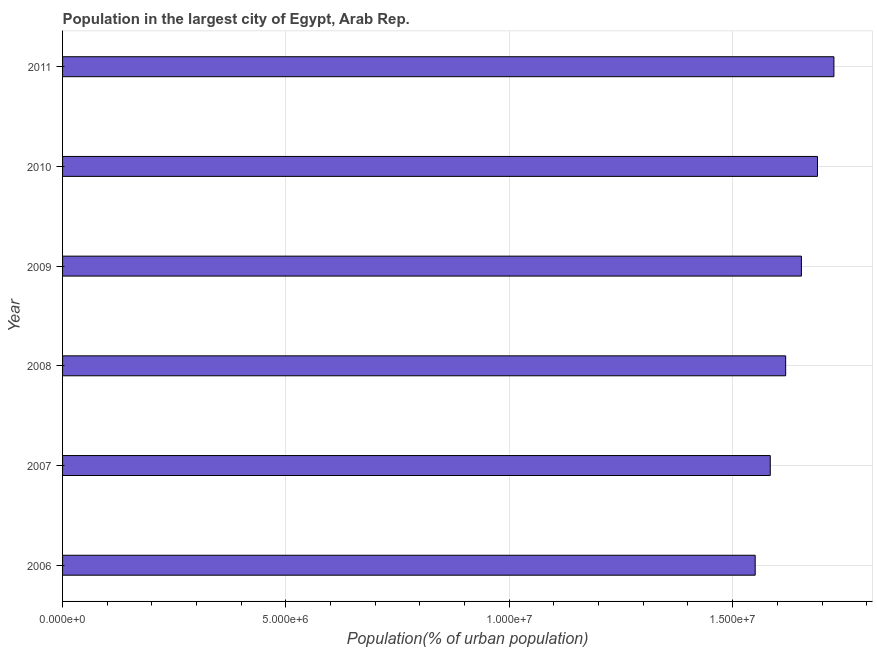Does the graph contain grids?
Provide a short and direct response. Yes. What is the title of the graph?
Your response must be concise. Population in the largest city of Egypt, Arab Rep. What is the label or title of the X-axis?
Your answer should be compact. Population(% of urban population). What is the label or title of the Y-axis?
Provide a short and direct response. Year. What is the population in largest city in 2007?
Provide a succinct answer. 1.58e+07. Across all years, what is the maximum population in largest city?
Provide a short and direct response. 1.73e+07. Across all years, what is the minimum population in largest city?
Provide a succinct answer. 1.55e+07. What is the sum of the population in largest city?
Offer a very short reply. 9.82e+07. What is the difference between the population in largest city in 2006 and 2010?
Give a very brief answer. -1.39e+06. What is the average population in largest city per year?
Ensure brevity in your answer.  1.64e+07. What is the median population in largest city?
Offer a very short reply. 1.64e+07. What is the ratio of the population in largest city in 2006 to that in 2009?
Offer a very short reply. 0.94. What is the difference between the highest and the second highest population in largest city?
Provide a succinct answer. 3.68e+05. What is the difference between the highest and the lowest population in largest city?
Ensure brevity in your answer.  1.76e+06. How many years are there in the graph?
Give a very brief answer. 6. Are the values on the major ticks of X-axis written in scientific E-notation?
Provide a short and direct response. Yes. What is the Population(% of urban population) of 2006?
Your answer should be very brief. 1.55e+07. What is the Population(% of urban population) of 2007?
Give a very brief answer. 1.58e+07. What is the Population(% of urban population) of 2008?
Offer a terse response. 1.62e+07. What is the Population(% of urban population) of 2009?
Your answer should be very brief. 1.65e+07. What is the Population(% of urban population) in 2010?
Your response must be concise. 1.69e+07. What is the Population(% of urban population) of 2011?
Keep it short and to the point. 1.73e+07. What is the difference between the Population(% of urban population) in 2006 and 2007?
Keep it short and to the point. -3.37e+05. What is the difference between the Population(% of urban population) in 2006 and 2008?
Offer a very short reply. -6.82e+05. What is the difference between the Population(% of urban population) in 2006 and 2009?
Keep it short and to the point. -1.03e+06. What is the difference between the Population(% of urban population) in 2006 and 2010?
Ensure brevity in your answer.  -1.39e+06. What is the difference between the Population(% of urban population) in 2006 and 2011?
Ensure brevity in your answer.  -1.76e+06. What is the difference between the Population(% of urban population) in 2007 and 2008?
Offer a terse response. -3.45e+05. What is the difference between the Population(% of urban population) in 2007 and 2009?
Ensure brevity in your answer.  -6.97e+05. What is the difference between the Population(% of urban population) in 2007 and 2010?
Your answer should be compact. -1.06e+06. What is the difference between the Population(% of urban population) in 2007 and 2011?
Give a very brief answer. -1.43e+06. What is the difference between the Population(% of urban population) in 2008 and 2009?
Give a very brief answer. -3.52e+05. What is the difference between the Population(% of urban population) in 2008 and 2010?
Offer a terse response. -7.12e+05. What is the difference between the Population(% of urban population) in 2008 and 2011?
Your answer should be very brief. -1.08e+06. What is the difference between the Population(% of urban population) in 2009 and 2010?
Your answer should be very brief. -3.60e+05. What is the difference between the Population(% of urban population) in 2009 and 2011?
Your answer should be very brief. -7.28e+05. What is the difference between the Population(% of urban population) in 2010 and 2011?
Your answer should be compact. -3.68e+05. What is the ratio of the Population(% of urban population) in 2006 to that in 2007?
Provide a short and direct response. 0.98. What is the ratio of the Population(% of urban population) in 2006 to that in 2008?
Keep it short and to the point. 0.96. What is the ratio of the Population(% of urban population) in 2006 to that in 2009?
Give a very brief answer. 0.94. What is the ratio of the Population(% of urban population) in 2006 to that in 2010?
Give a very brief answer. 0.92. What is the ratio of the Population(% of urban population) in 2006 to that in 2011?
Offer a very short reply. 0.9. What is the ratio of the Population(% of urban population) in 2007 to that in 2008?
Your answer should be compact. 0.98. What is the ratio of the Population(% of urban population) in 2007 to that in 2009?
Make the answer very short. 0.96. What is the ratio of the Population(% of urban population) in 2007 to that in 2010?
Give a very brief answer. 0.94. What is the ratio of the Population(% of urban population) in 2007 to that in 2011?
Provide a short and direct response. 0.92. What is the ratio of the Population(% of urban population) in 2008 to that in 2009?
Give a very brief answer. 0.98. What is the ratio of the Population(% of urban population) in 2008 to that in 2010?
Provide a short and direct response. 0.96. What is the ratio of the Population(% of urban population) in 2008 to that in 2011?
Give a very brief answer. 0.94. What is the ratio of the Population(% of urban population) in 2009 to that in 2011?
Your response must be concise. 0.96. 